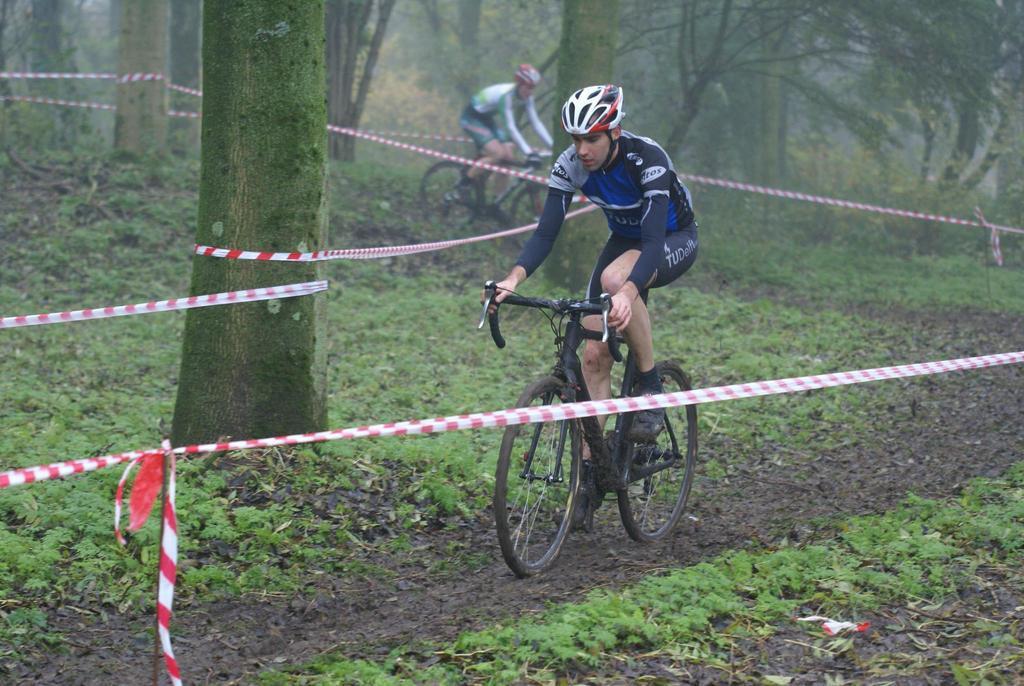Describe this image in one or two sentences. In this picture there are two persons riding bicycles and there is an object which is in red and white color is around them and there are trees in the background. 